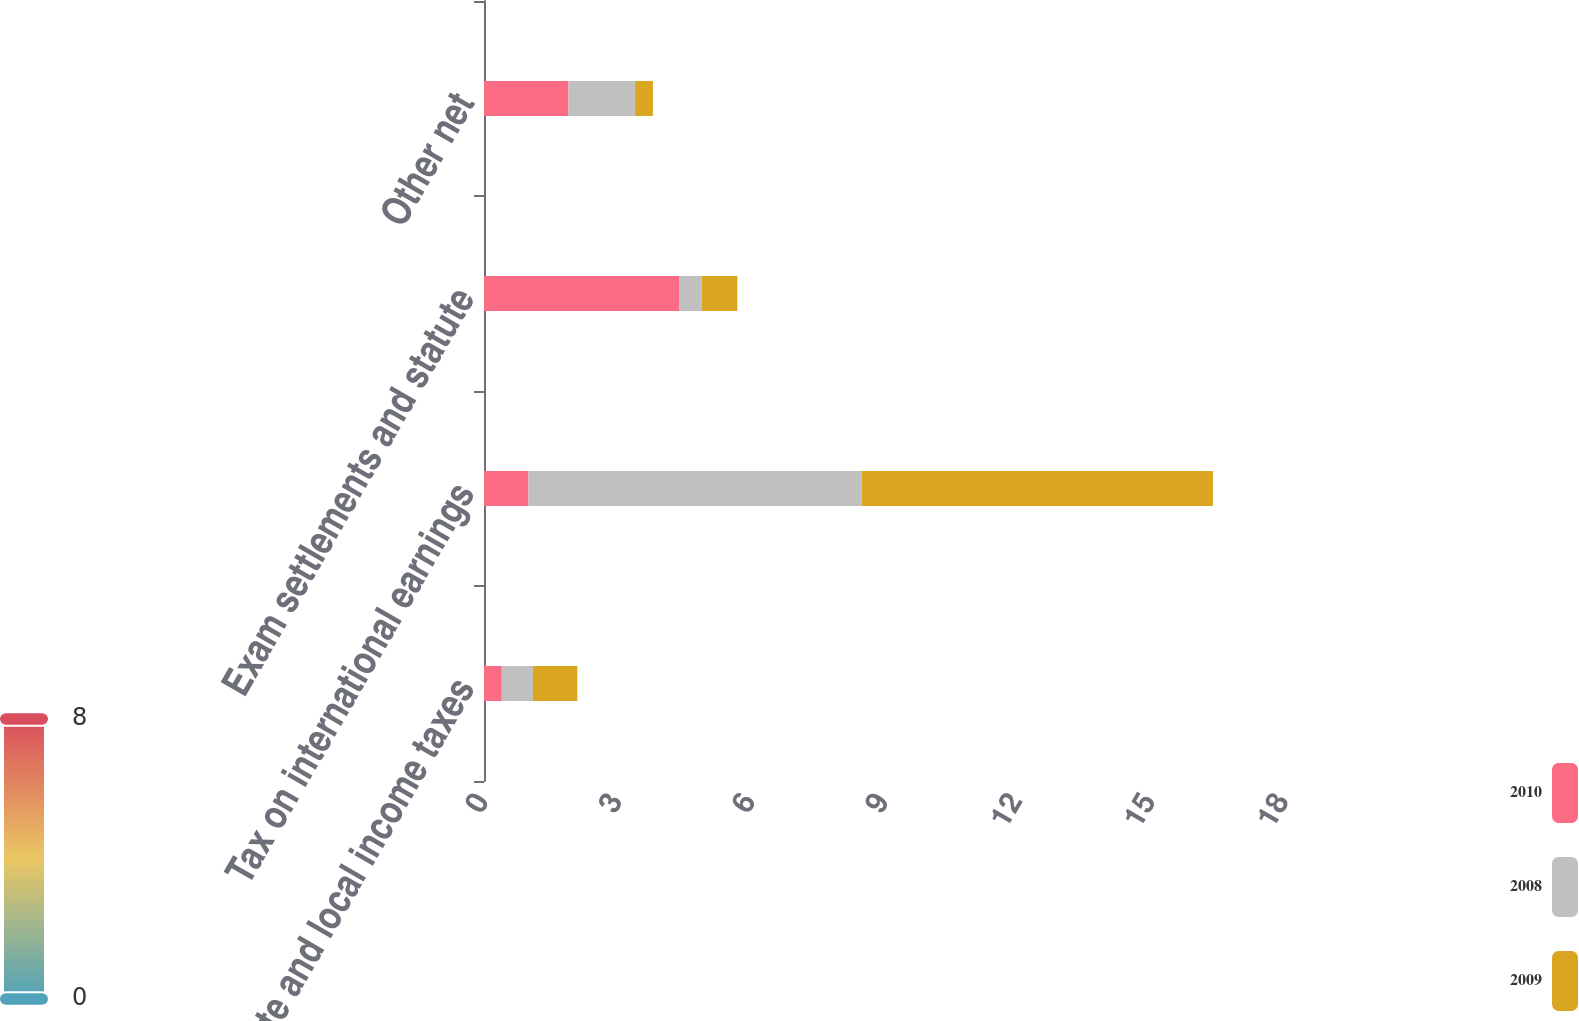<chart> <loc_0><loc_0><loc_500><loc_500><stacked_bar_chart><ecel><fcel>State and local income taxes<fcel>Tax on international earnings<fcel>Exam settlements and statute<fcel>Other net<nl><fcel>2010<fcel>0.4<fcel>1<fcel>4.4<fcel>1.9<nl><fcel>2008<fcel>0.7<fcel>7.5<fcel>0.5<fcel>1.5<nl><fcel>2009<fcel>1<fcel>7.9<fcel>0.8<fcel>0.4<nl></chart> 